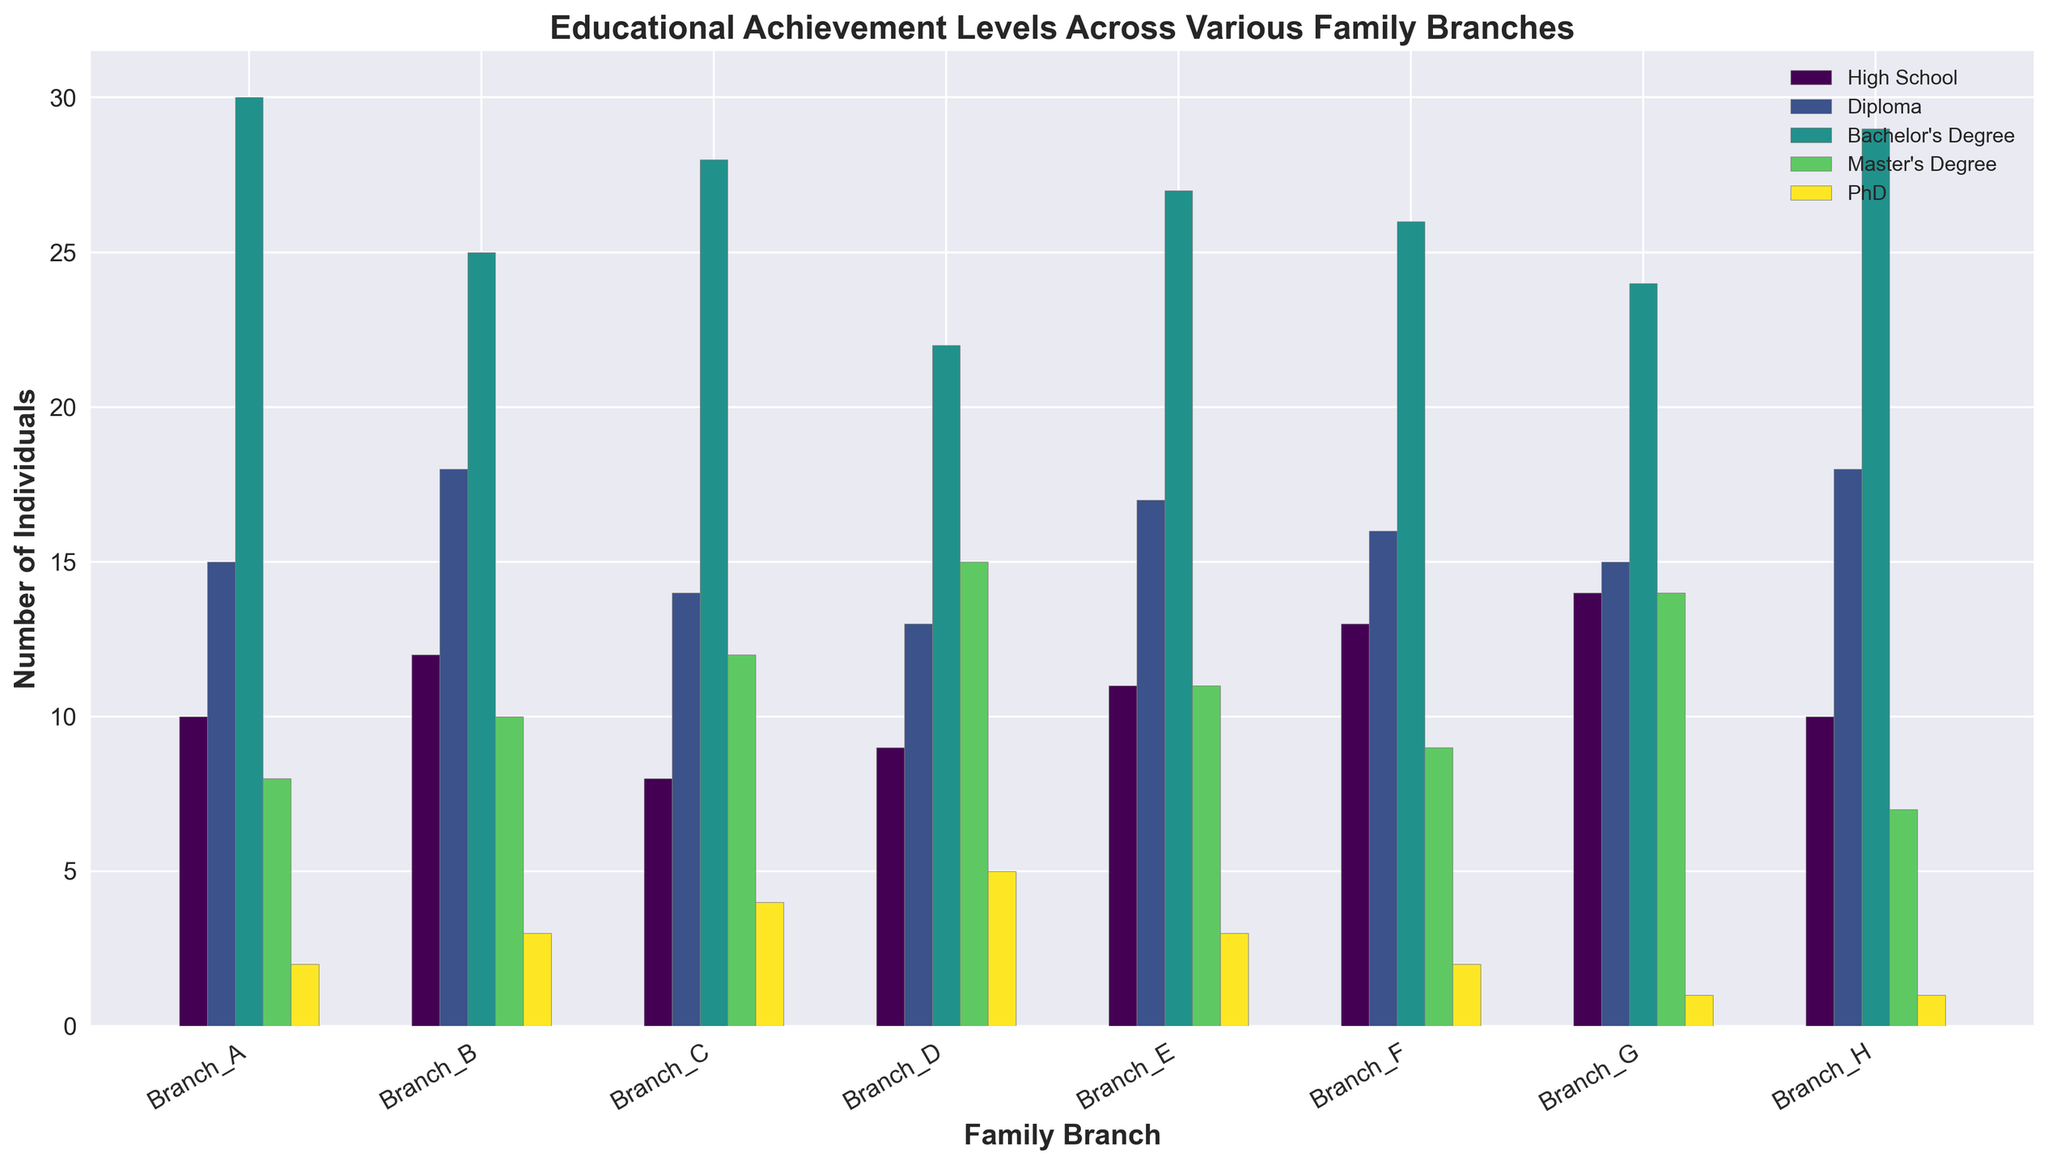Which family branch has the highest number of individuals with a Bachelor's Degree? Look at the bars representing Bachelor's Degree for each family branch and compare their heights. Branch A has 30, which is the highest among all.
Answer: Branch_A What is the total number of individuals with a PhD across all family branches? Sum the number of individuals with a PhD from each family branch: 2 (A) + 3 (B) + 4 (C) + 5 (D) + 3 (E) + 2 (F) + 1 (G) + 1 (H) = 21.
Answer: 21 How many more individuals in Branch D have a Master's Degree compared to Branch G? Subtract the number of individuals with a Master's Degree in Branch G from those in Branch D: 15 (D) - 14 (G) = 1.
Answer: 1 Which two family branches have the same number of individuals with High School education, and what is that number? Compare the bars for High School education and find the ones with the same height: Branch A and Branch H both have 10 individuals.
Answer: Branch_A and Branch_H, 10 Between Branch E and Branch F, which branch has more individuals with a Diploma, and by how much? Compare the heights of the bars for Diploma: Branch F has 16 and Branch E has 17. Subtract 16 from 17 to get the difference.
Answer: Branch_E, 1 What is the average number of individuals with a Master's Degree per family branch? Calculate the total number of individuals with a Master's Degree then divide by the number of family branches: (8 (A) + 10 (B) + 12 (C) + 15 (D) + 11 (E) + 9 (F) + 14 (G) + 7 (H)) / 8 = 86 / 8 = 10.75.
Answer: 10.75 Which family branch has the lowest total number of individuals with at least a Diploma? Add the numbers for Diploma, Bachelor's Degree, Master's Degree, and PhD for each family branch and compare: Branch D has the lowest total of 13 + 22 + 15 + 5 = 55.
Answer: Branch_D In which family branch are the differences between the number of individuals with High School and Bachelor's Degree the greatest? Calculate the differences for each branch and find the maximum: Branch A has a difference of 30 - 10 = 20, which is the greatest.
Answer: Branch_A 